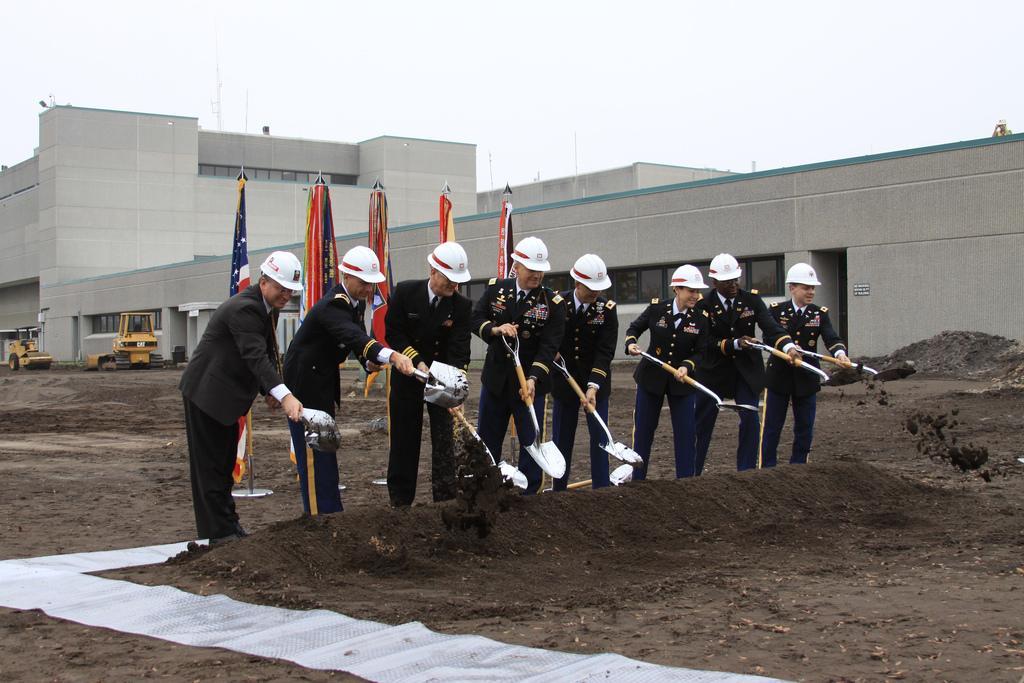In one or two sentences, can you explain what this image depicts? In this image we can see a group of people holding an object in front of sand, behind them, we can also see buildings, vehicles, poles, for flags and the sky. There we can also a see a mat near the persons. 